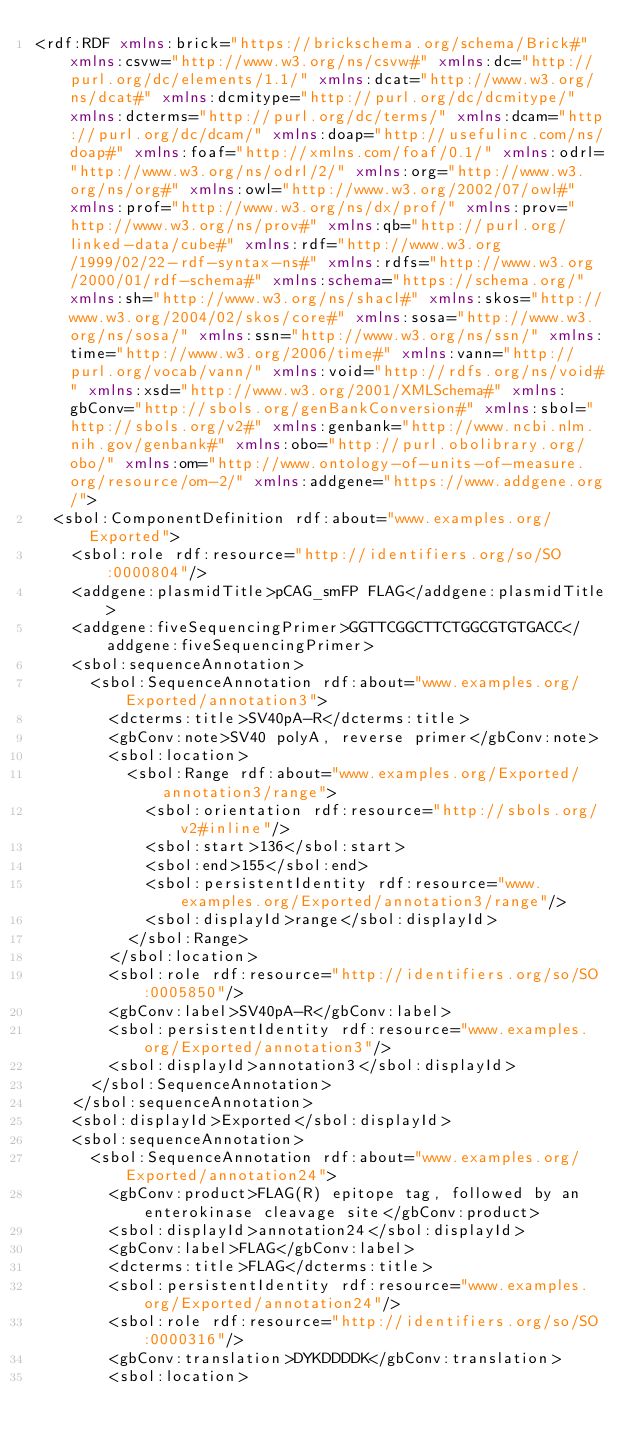<code> <loc_0><loc_0><loc_500><loc_500><_XML_><rdf:RDF xmlns:brick="https://brickschema.org/schema/Brick#" xmlns:csvw="http://www.w3.org/ns/csvw#" xmlns:dc="http://purl.org/dc/elements/1.1/" xmlns:dcat="http://www.w3.org/ns/dcat#" xmlns:dcmitype="http://purl.org/dc/dcmitype/" xmlns:dcterms="http://purl.org/dc/terms/" xmlns:dcam="http://purl.org/dc/dcam/" xmlns:doap="http://usefulinc.com/ns/doap#" xmlns:foaf="http://xmlns.com/foaf/0.1/" xmlns:odrl="http://www.w3.org/ns/odrl/2/" xmlns:org="http://www.w3.org/ns/org#" xmlns:owl="http://www.w3.org/2002/07/owl#" xmlns:prof="http://www.w3.org/ns/dx/prof/" xmlns:prov="http://www.w3.org/ns/prov#" xmlns:qb="http://purl.org/linked-data/cube#" xmlns:rdf="http://www.w3.org/1999/02/22-rdf-syntax-ns#" xmlns:rdfs="http://www.w3.org/2000/01/rdf-schema#" xmlns:schema="https://schema.org/" xmlns:sh="http://www.w3.org/ns/shacl#" xmlns:skos="http://www.w3.org/2004/02/skos/core#" xmlns:sosa="http://www.w3.org/ns/sosa/" xmlns:ssn="http://www.w3.org/ns/ssn/" xmlns:time="http://www.w3.org/2006/time#" xmlns:vann="http://purl.org/vocab/vann/" xmlns:void="http://rdfs.org/ns/void#" xmlns:xsd="http://www.w3.org/2001/XMLSchema#" xmlns:gbConv="http://sbols.org/genBankConversion#" xmlns:sbol="http://sbols.org/v2#" xmlns:genbank="http://www.ncbi.nlm.nih.gov/genbank#" xmlns:obo="http://purl.obolibrary.org/obo/" xmlns:om="http://www.ontology-of-units-of-measure.org/resource/om-2/" xmlns:addgene="https://www.addgene.org/">
  <sbol:ComponentDefinition rdf:about="www.examples.org/Exported">
    <sbol:role rdf:resource="http://identifiers.org/so/SO:0000804"/>
    <addgene:plasmidTitle>pCAG_smFP FLAG</addgene:plasmidTitle>
    <addgene:fiveSequencingPrimer>GGTTCGGCTTCTGGCGTGTGACC</addgene:fiveSequencingPrimer>
    <sbol:sequenceAnnotation>
      <sbol:SequenceAnnotation rdf:about="www.examples.org/Exported/annotation3">
        <dcterms:title>SV40pA-R</dcterms:title>
        <gbConv:note>SV40 polyA, reverse primer</gbConv:note>
        <sbol:location>
          <sbol:Range rdf:about="www.examples.org/Exported/annotation3/range">
            <sbol:orientation rdf:resource="http://sbols.org/v2#inline"/>
            <sbol:start>136</sbol:start>
            <sbol:end>155</sbol:end>
            <sbol:persistentIdentity rdf:resource="www.examples.org/Exported/annotation3/range"/>
            <sbol:displayId>range</sbol:displayId>
          </sbol:Range>
        </sbol:location>
        <sbol:role rdf:resource="http://identifiers.org/so/SO:0005850"/>
        <gbConv:label>SV40pA-R</gbConv:label>
        <sbol:persistentIdentity rdf:resource="www.examples.org/Exported/annotation3"/>
        <sbol:displayId>annotation3</sbol:displayId>
      </sbol:SequenceAnnotation>
    </sbol:sequenceAnnotation>
    <sbol:displayId>Exported</sbol:displayId>
    <sbol:sequenceAnnotation>
      <sbol:SequenceAnnotation rdf:about="www.examples.org/Exported/annotation24">
        <gbConv:product>FLAG(R) epitope tag, followed by an enterokinase cleavage site</gbConv:product>
        <sbol:displayId>annotation24</sbol:displayId>
        <gbConv:label>FLAG</gbConv:label>
        <dcterms:title>FLAG</dcterms:title>
        <sbol:persistentIdentity rdf:resource="www.examples.org/Exported/annotation24"/>
        <sbol:role rdf:resource="http://identifiers.org/so/SO:0000316"/>
        <gbConv:translation>DYKDDDDK</gbConv:translation>
        <sbol:location></code> 